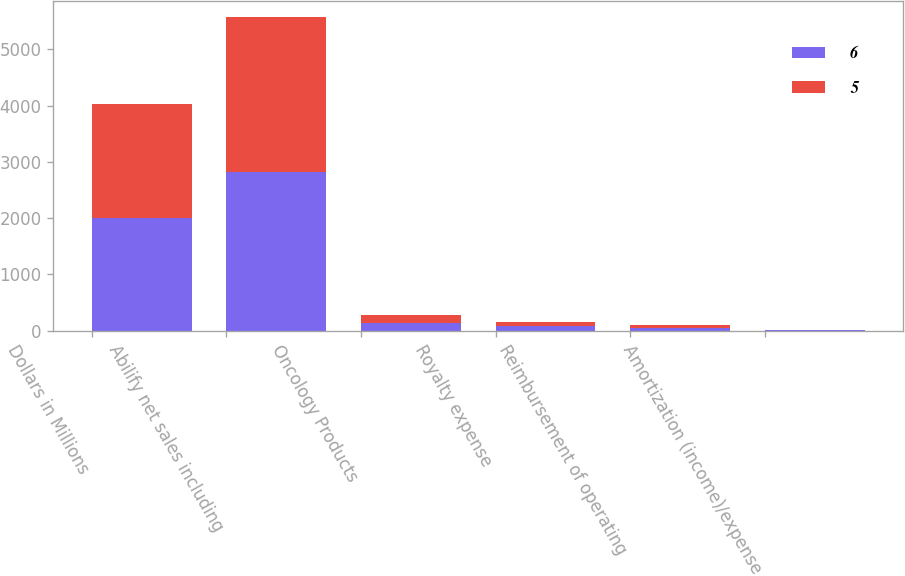Convert chart to OTSL. <chart><loc_0><loc_0><loc_500><loc_500><stacked_bar_chart><ecel><fcel>Dollars in Millions<fcel>Abilify net sales including<fcel>Oncology Products<fcel>Royalty expense<fcel>Reimbursement of operating<fcel>Amortization (income)/expense<nl><fcel>6<fcel>2012<fcel>2827<fcel>138<fcel>78<fcel>49<fcel>5<nl><fcel>5<fcel>2011<fcel>2758<fcel>134<fcel>72<fcel>47<fcel>6<nl></chart> 